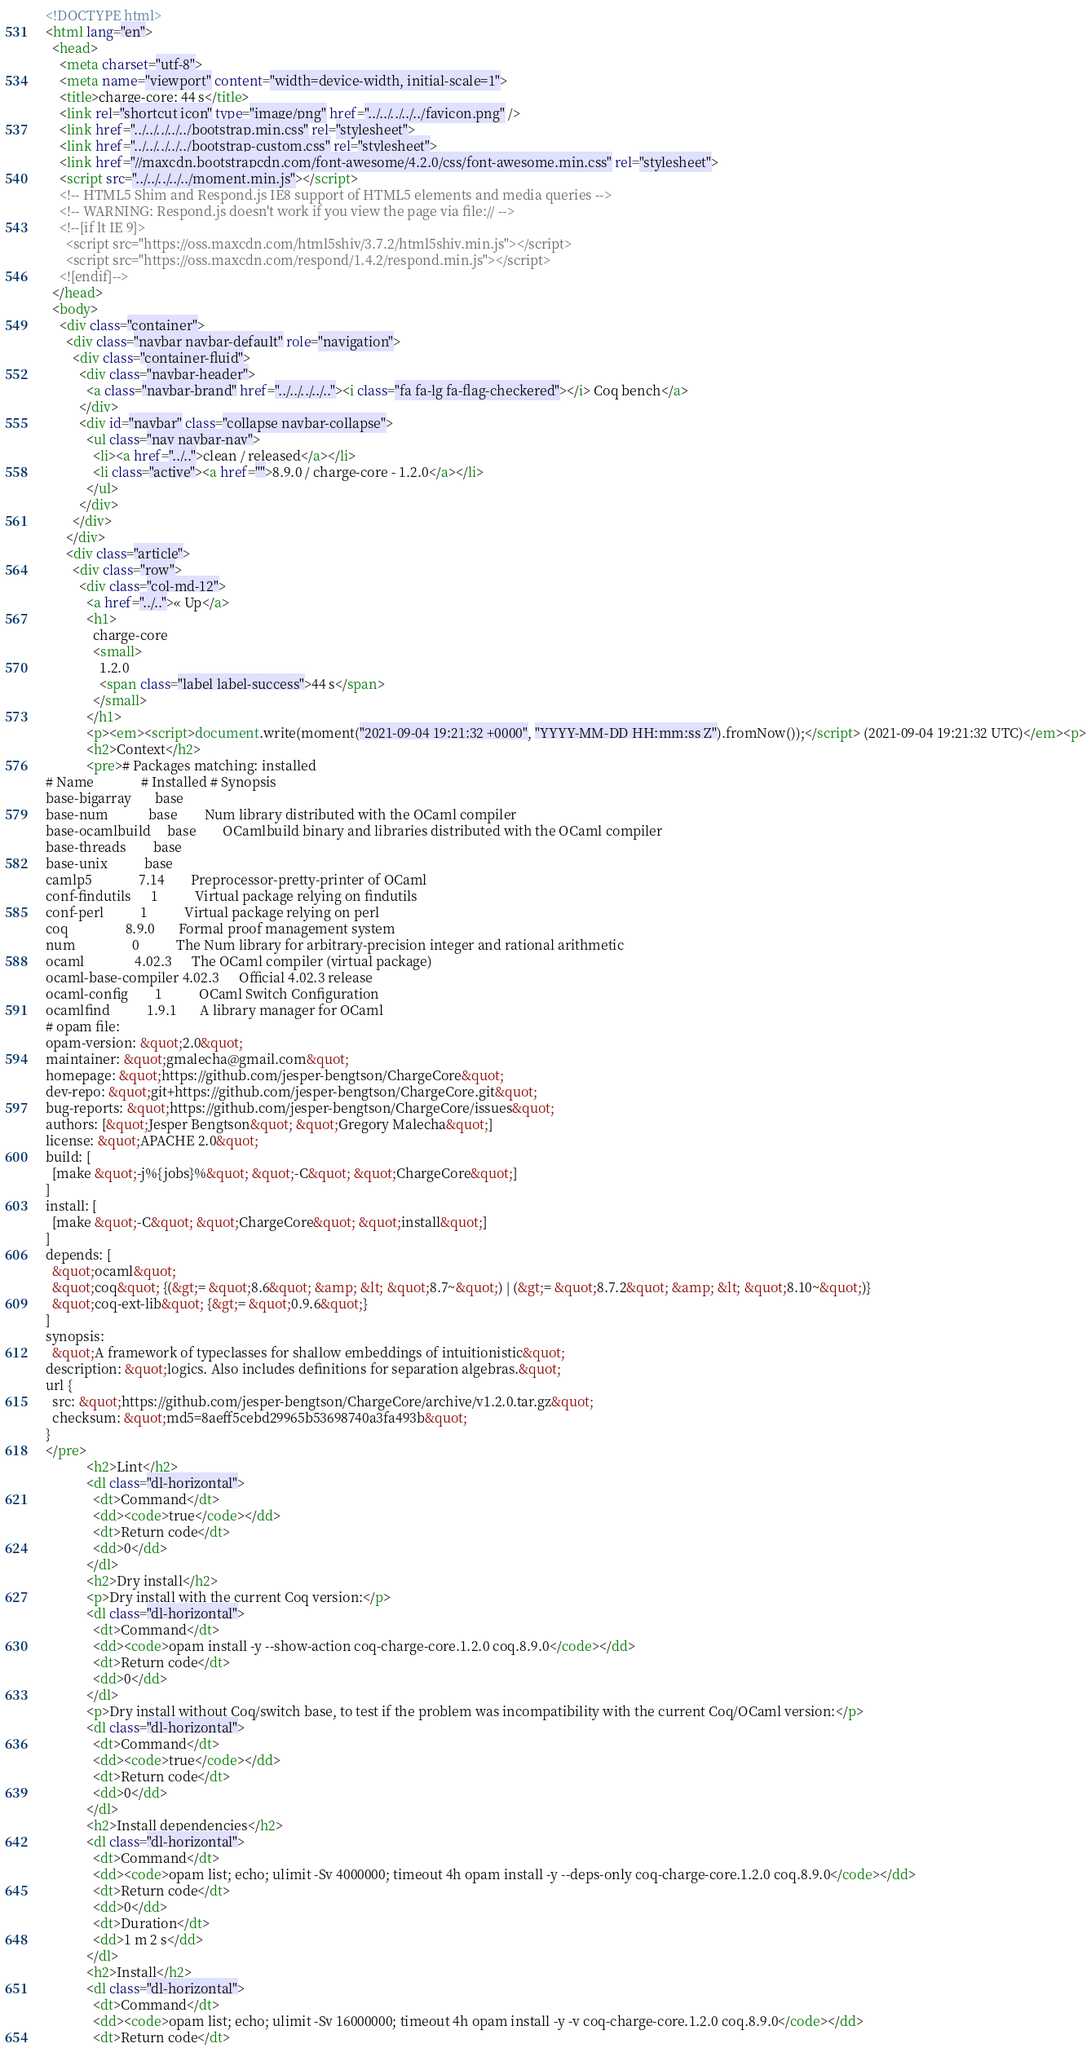<code> <loc_0><loc_0><loc_500><loc_500><_HTML_><!DOCTYPE html>
<html lang="en">
  <head>
    <meta charset="utf-8">
    <meta name="viewport" content="width=device-width, initial-scale=1">
    <title>charge-core: 44 s</title>
    <link rel="shortcut icon" type="image/png" href="../../../../../favicon.png" />
    <link href="../../../../../bootstrap.min.css" rel="stylesheet">
    <link href="../../../../../bootstrap-custom.css" rel="stylesheet">
    <link href="//maxcdn.bootstrapcdn.com/font-awesome/4.2.0/css/font-awesome.min.css" rel="stylesheet">
    <script src="../../../../../moment.min.js"></script>
    <!-- HTML5 Shim and Respond.js IE8 support of HTML5 elements and media queries -->
    <!-- WARNING: Respond.js doesn't work if you view the page via file:// -->
    <!--[if lt IE 9]>
      <script src="https://oss.maxcdn.com/html5shiv/3.7.2/html5shiv.min.js"></script>
      <script src="https://oss.maxcdn.com/respond/1.4.2/respond.min.js"></script>
    <![endif]-->
  </head>
  <body>
    <div class="container">
      <div class="navbar navbar-default" role="navigation">
        <div class="container-fluid">
          <div class="navbar-header">
            <a class="navbar-brand" href="../../../../.."><i class="fa fa-lg fa-flag-checkered"></i> Coq bench</a>
          </div>
          <div id="navbar" class="collapse navbar-collapse">
            <ul class="nav navbar-nav">
              <li><a href="../..">clean / released</a></li>
              <li class="active"><a href="">8.9.0 / charge-core - 1.2.0</a></li>
            </ul>
          </div>
        </div>
      </div>
      <div class="article">
        <div class="row">
          <div class="col-md-12">
            <a href="../..">« Up</a>
            <h1>
              charge-core
              <small>
                1.2.0
                <span class="label label-success">44 s</span>
              </small>
            </h1>
            <p><em><script>document.write(moment("2021-09-04 19:21:32 +0000", "YYYY-MM-DD HH:mm:ss Z").fromNow());</script> (2021-09-04 19:21:32 UTC)</em><p>
            <h2>Context</h2>
            <pre># Packages matching: installed
# Name              # Installed # Synopsis
base-bigarray       base
base-num            base        Num library distributed with the OCaml compiler
base-ocamlbuild     base        OCamlbuild binary and libraries distributed with the OCaml compiler
base-threads        base
base-unix           base
camlp5              7.14        Preprocessor-pretty-printer of OCaml
conf-findutils      1           Virtual package relying on findutils
conf-perl           1           Virtual package relying on perl
coq                 8.9.0       Formal proof management system
num                 0           The Num library for arbitrary-precision integer and rational arithmetic
ocaml               4.02.3      The OCaml compiler (virtual package)
ocaml-base-compiler 4.02.3      Official 4.02.3 release
ocaml-config        1           OCaml Switch Configuration
ocamlfind           1.9.1       A library manager for OCaml
# opam file:
opam-version: &quot;2.0&quot;
maintainer: &quot;gmalecha@gmail.com&quot;
homepage: &quot;https://github.com/jesper-bengtson/ChargeCore&quot;
dev-repo: &quot;git+https://github.com/jesper-bengtson/ChargeCore.git&quot;
bug-reports: &quot;https://github.com/jesper-bengtson/ChargeCore/issues&quot;
authors: [&quot;Jesper Bengtson&quot; &quot;Gregory Malecha&quot;]
license: &quot;APACHE 2.0&quot;
build: [
  [make &quot;-j%{jobs}%&quot; &quot;-C&quot; &quot;ChargeCore&quot;]
]
install: [
  [make &quot;-C&quot; &quot;ChargeCore&quot; &quot;install&quot;]
]
depends: [
  &quot;ocaml&quot;
  &quot;coq&quot; {(&gt;= &quot;8.6&quot; &amp; &lt; &quot;8.7~&quot;) | (&gt;= &quot;8.7.2&quot; &amp; &lt; &quot;8.10~&quot;)}
  &quot;coq-ext-lib&quot; {&gt;= &quot;0.9.6&quot;}
]
synopsis:
  &quot;A framework of typeclasses for shallow embeddings of intuitionistic&quot;
description: &quot;logics. Also includes definitions for separation algebras.&quot;
url {
  src: &quot;https://github.com/jesper-bengtson/ChargeCore/archive/v1.2.0.tar.gz&quot;
  checksum: &quot;md5=8aeff5cebd29965b53698740a3fa493b&quot;
}
</pre>
            <h2>Lint</h2>
            <dl class="dl-horizontal">
              <dt>Command</dt>
              <dd><code>true</code></dd>
              <dt>Return code</dt>
              <dd>0</dd>
            </dl>
            <h2>Dry install</h2>
            <p>Dry install with the current Coq version:</p>
            <dl class="dl-horizontal">
              <dt>Command</dt>
              <dd><code>opam install -y --show-action coq-charge-core.1.2.0 coq.8.9.0</code></dd>
              <dt>Return code</dt>
              <dd>0</dd>
            </dl>
            <p>Dry install without Coq/switch base, to test if the problem was incompatibility with the current Coq/OCaml version:</p>
            <dl class="dl-horizontal">
              <dt>Command</dt>
              <dd><code>true</code></dd>
              <dt>Return code</dt>
              <dd>0</dd>
            </dl>
            <h2>Install dependencies</h2>
            <dl class="dl-horizontal">
              <dt>Command</dt>
              <dd><code>opam list; echo; ulimit -Sv 4000000; timeout 4h opam install -y --deps-only coq-charge-core.1.2.0 coq.8.9.0</code></dd>
              <dt>Return code</dt>
              <dd>0</dd>
              <dt>Duration</dt>
              <dd>1 m 2 s</dd>
            </dl>
            <h2>Install</h2>
            <dl class="dl-horizontal">
              <dt>Command</dt>
              <dd><code>opam list; echo; ulimit -Sv 16000000; timeout 4h opam install -y -v coq-charge-core.1.2.0 coq.8.9.0</code></dd>
              <dt>Return code</dt></code> 